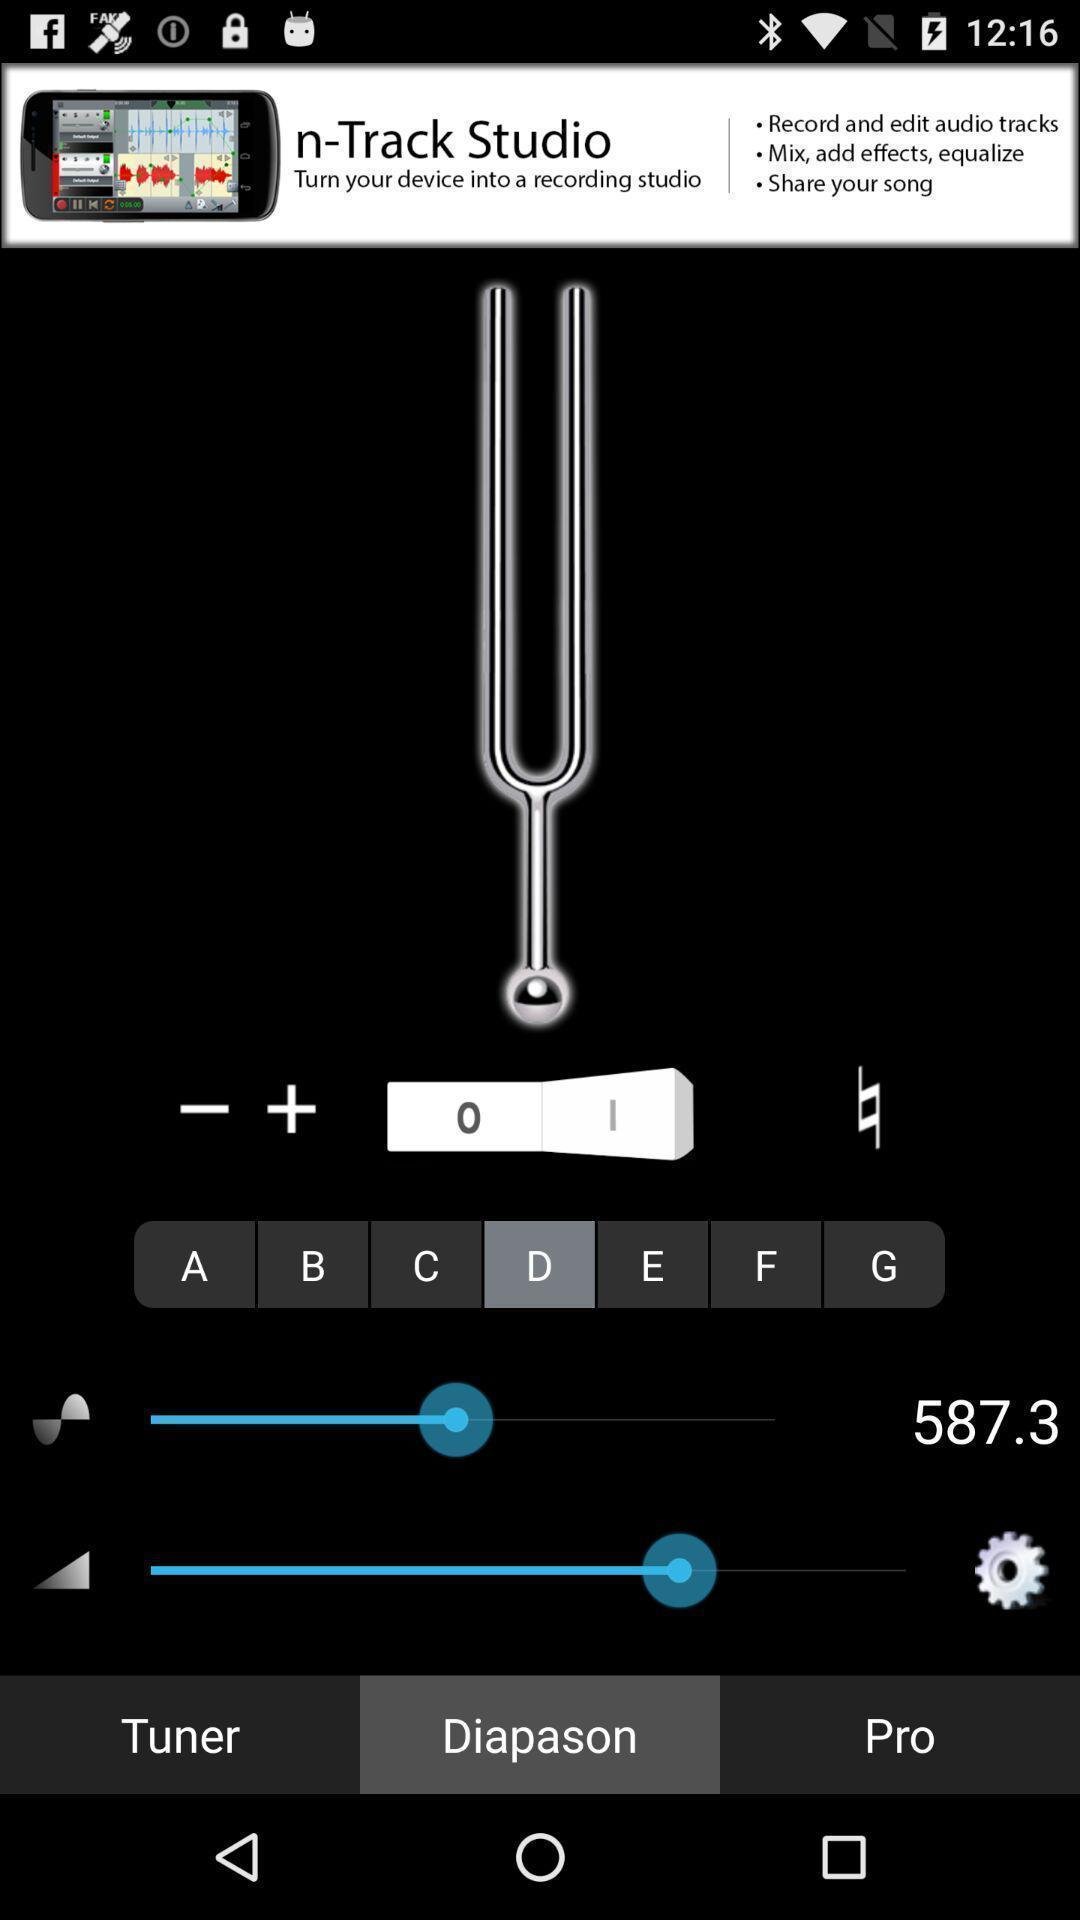What is the overall content of this screenshot? Page showing sound settings in a music app. 